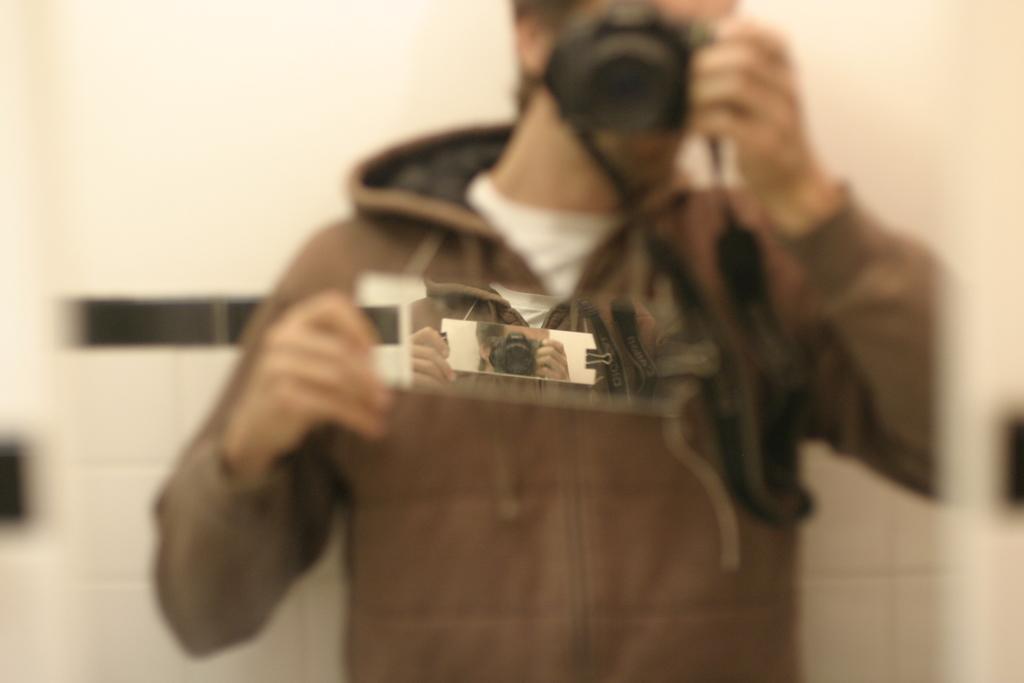Describe this image in one or two sentences. In this image there is man standing in front of the mirror and taking a picture in the camera. He is wearing a brown colored jacket. 